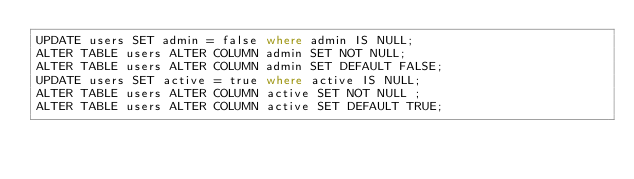<code> <loc_0><loc_0><loc_500><loc_500><_SQL_>UPDATE users SET admin = false where admin IS NULL;
ALTER TABLE users ALTER COLUMN admin SET NOT NULL;
ALTER TABLE users ALTER COLUMN admin SET DEFAULT FALSE;
UPDATE users SET active = true where active IS NULL;
ALTER TABLE users ALTER COLUMN active SET NOT NULL ;
ALTER TABLE users ALTER COLUMN active SET DEFAULT TRUE;
</code> 